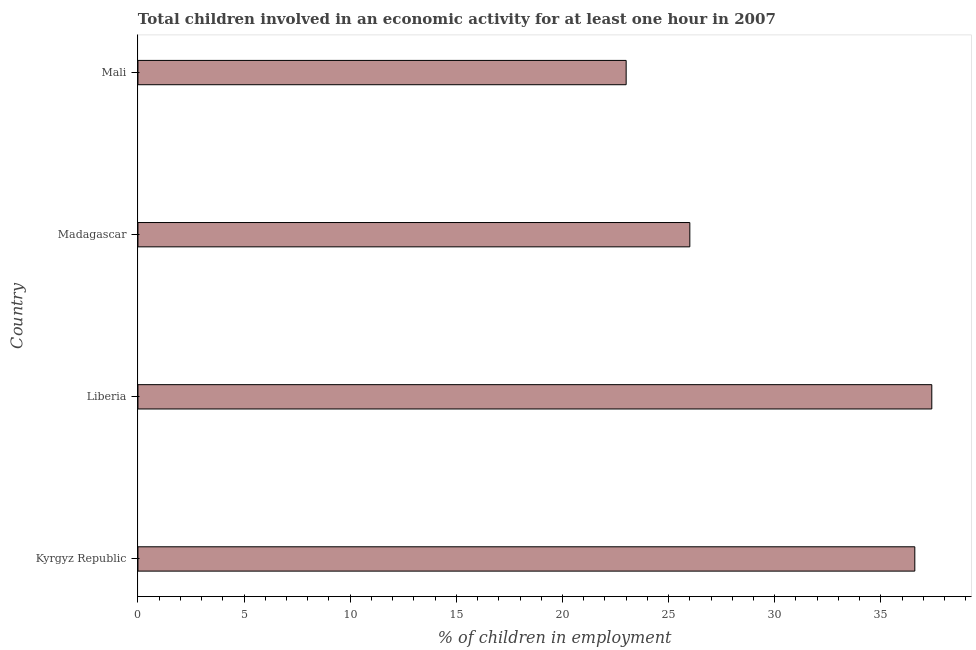Does the graph contain any zero values?
Keep it short and to the point. No. What is the title of the graph?
Give a very brief answer. Total children involved in an economic activity for at least one hour in 2007. What is the label or title of the X-axis?
Ensure brevity in your answer.  % of children in employment. What is the percentage of children in employment in Mali?
Give a very brief answer. 23. Across all countries, what is the maximum percentage of children in employment?
Provide a succinct answer. 37.4. Across all countries, what is the minimum percentage of children in employment?
Your answer should be compact. 23. In which country was the percentage of children in employment maximum?
Your response must be concise. Liberia. In which country was the percentage of children in employment minimum?
Keep it short and to the point. Mali. What is the sum of the percentage of children in employment?
Ensure brevity in your answer.  123. What is the average percentage of children in employment per country?
Offer a very short reply. 30.75. What is the median percentage of children in employment?
Offer a terse response. 31.3. What is the ratio of the percentage of children in employment in Kyrgyz Republic to that in Liberia?
Provide a succinct answer. 0.98. Is the percentage of children in employment in Madagascar less than that in Mali?
Give a very brief answer. No. Is the sum of the percentage of children in employment in Liberia and Madagascar greater than the maximum percentage of children in employment across all countries?
Ensure brevity in your answer.  Yes. What is the difference between the highest and the lowest percentage of children in employment?
Give a very brief answer. 14.4. How many bars are there?
Give a very brief answer. 4. Are all the bars in the graph horizontal?
Provide a succinct answer. Yes. How many countries are there in the graph?
Provide a succinct answer. 4. What is the difference between two consecutive major ticks on the X-axis?
Offer a terse response. 5. Are the values on the major ticks of X-axis written in scientific E-notation?
Provide a succinct answer. No. What is the % of children in employment in Kyrgyz Republic?
Keep it short and to the point. 36.6. What is the % of children in employment of Liberia?
Offer a terse response. 37.4. What is the difference between the % of children in employment in Kyrgyz Republic and Liberia?
Keep it short and to the point. -0.8. What is the difference between the % of children in employment in Kyrgyz Republic and Madagascar?
Make the answer very short. 10.6. What is the difference between the % of children in employment in Liberia and Madagascar?
Provide a short and direct response. 11.4. What is the difference between the % of children in employment in Madagascar and Mali?
Give a very brief answer. 3. What is the ratio of the % of children in employment in Kyrgyz Republic to that in Liberia?
Provide a short and direct response. 0.98. What is the ratio of the % of children in employment in Kyrgyz Republic to that in Madagascar?
Provide a short and direct response. 1.41. What is the ratio of the % of children in employment in Kyrgyz Republic to that in Mali?
Provide a short and direct response. 1.59. What is the ratio of the % of children in employment in Liberia to that in Madagascar?
Your answer should be compact. 1.44. What is the ratio of the % of children in employment in Liberia to that in Mali?
Provide a short and direct response. 1.63. What is the ratio of the % of children in employment in Madagascar to that in Mali?
Offer a terse response. 1.13. 